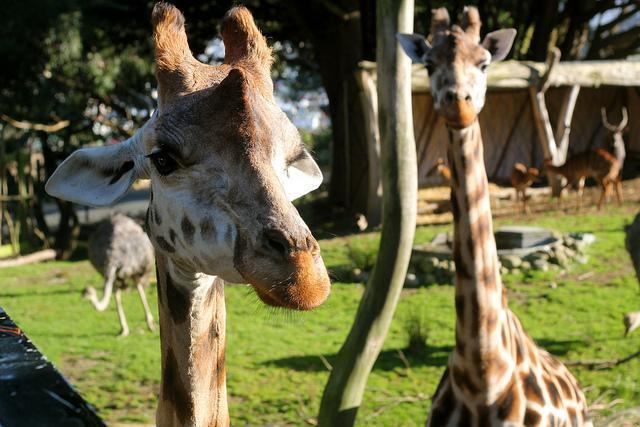How many birds on this picture?
Give a very brief answer. 1. How many giraffes can you see?
Give a very brief answer. 2. 